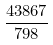<formula> <loc_0><loc_0><loc_500><loc_500>\frac { 4 3 8 6 7 } { 7 9 8 }</formula> 